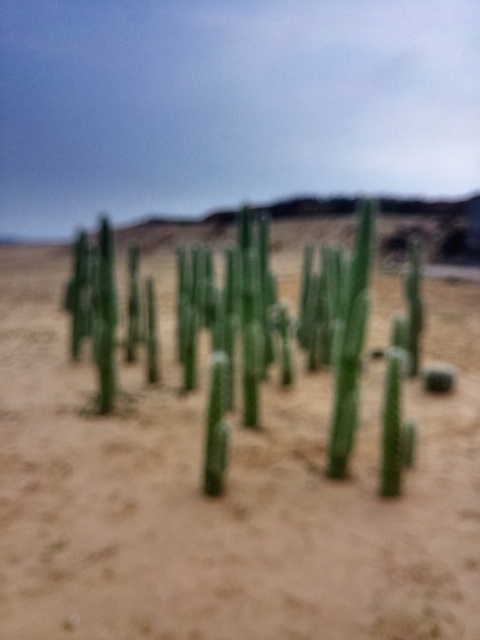What time of day does this image seem to capture? The diffuse lighting and overcast sky suggest it could be early morning or late afternoon. There are no harsh shadows that would indicate midday sun. 